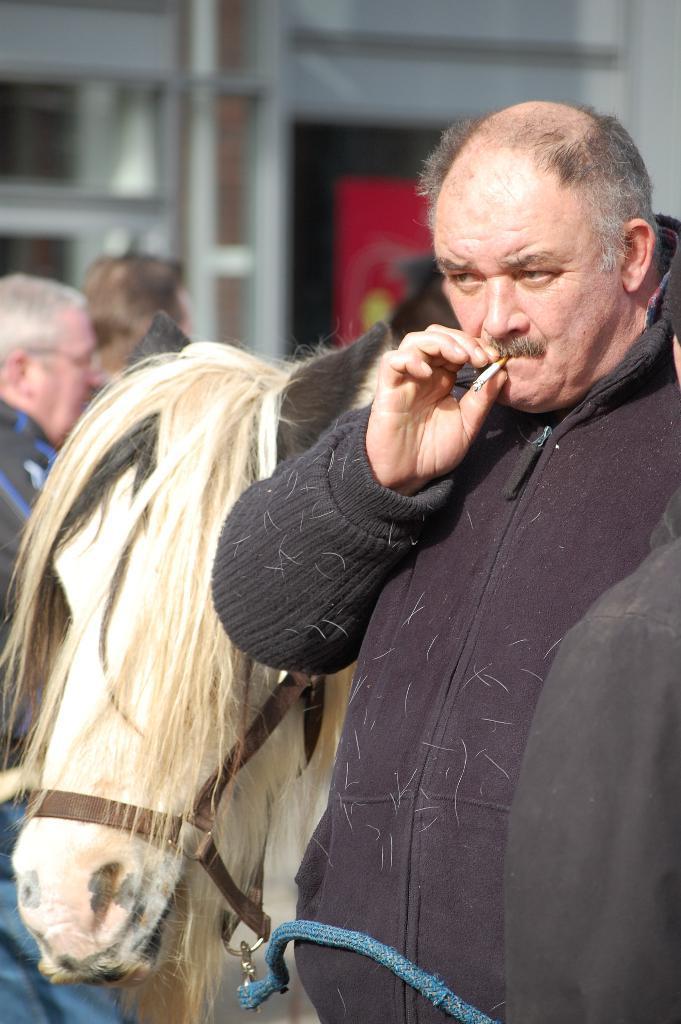Describe this image in one or two sentences. In this image there is a man who is holding the cigar. Behind him there is a horse. In the background there are few people who are standing on the ground. 